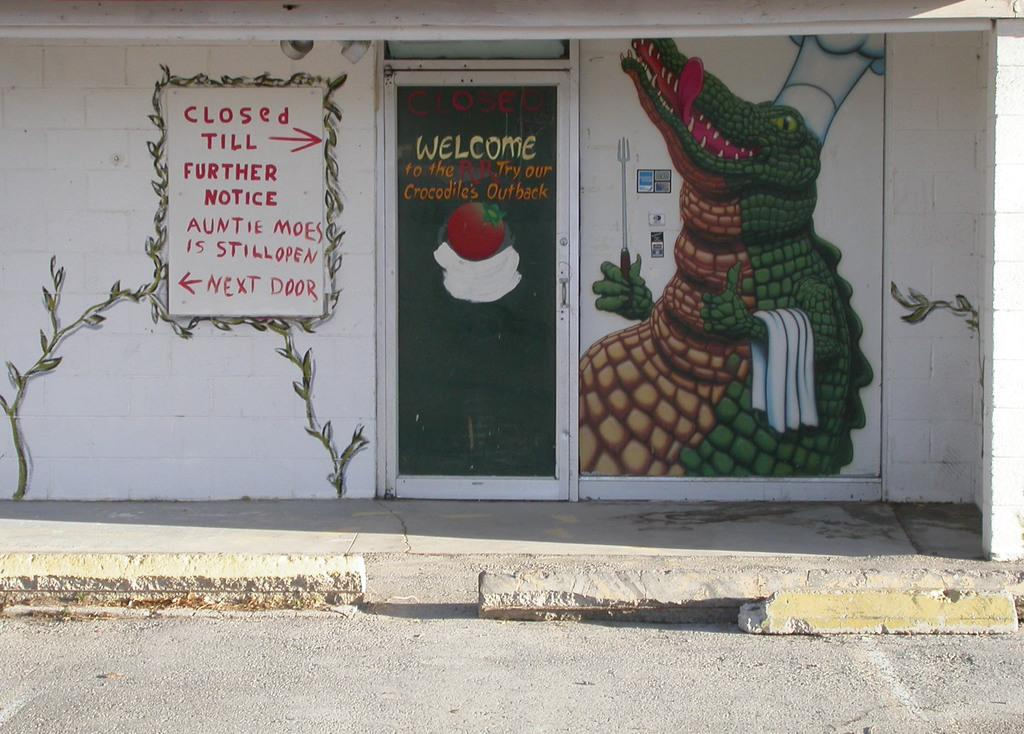What is the setting of the image? The image is an outside view. What can be seen at the bottom of the image? There is a road at the bottom of the image. What structure is visible in the background of the image? There is a door in the background of the image. What is the door a part of? The door is part of a wall. What decorative elements are present on the wall? There are paintings and text on the wall. What type of plantation can be seen in the image? There is no plantation present in the image. How many corn stalks are visible in the image? There are no corn stalks visible in the image. 